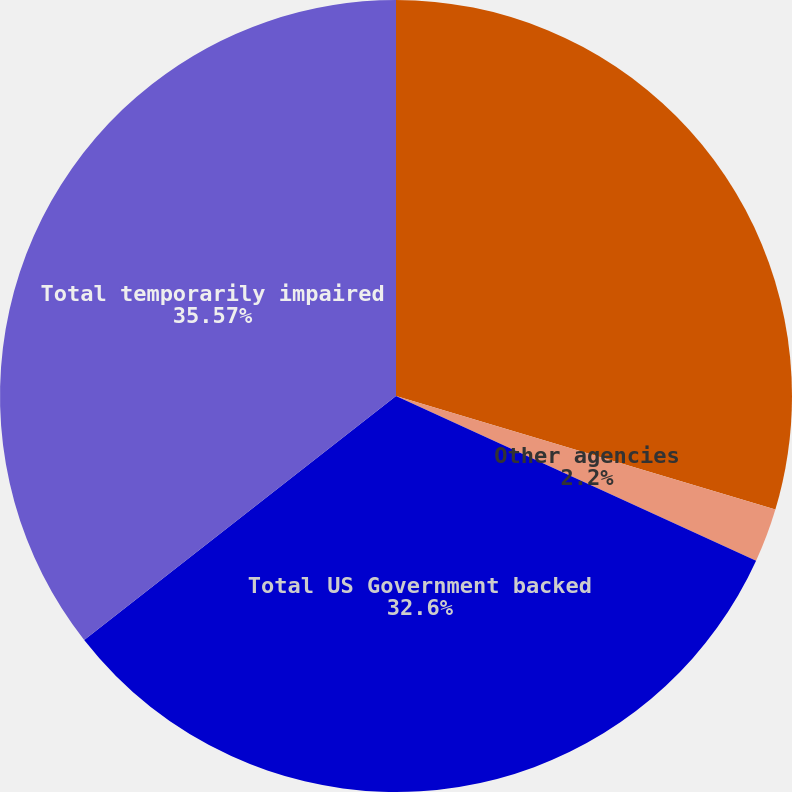<chart> <loc_0><loc_0><loc_500><loc_500><pie_chart><fcel>Mortgage-backed securities<fcel>Other agencies<fcel>Total US Government backed<fcel>Total temporarily impaired<nl><fcel>29.63%<fcel>2.2%<fcel>32.6%<fcel>35.57%<nl></chart> 